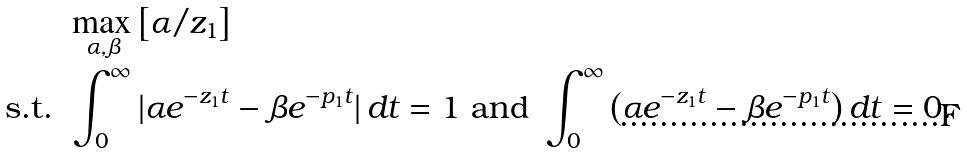<formula> <loc_0><loc_0><loc_500><loc_500>& \max _ { \alpha , \beta } \left [ \alpha / z _ { 1 } \right ] \\ \text {s.t. } & \int _ { 0 } ^ { \infty } | \alpha e ^ { - z _ { 1 } t } - \beta e ^ { - p _ { 1 } t } | \, d t = 1 \text { and } \int _ { 0 } ^ { \infty } \left ( \alpha e ^ { - z _ { 1 } t } - \beta e ^ { - p _ { 1 } t } \right ) d t = 0 .</formula> 